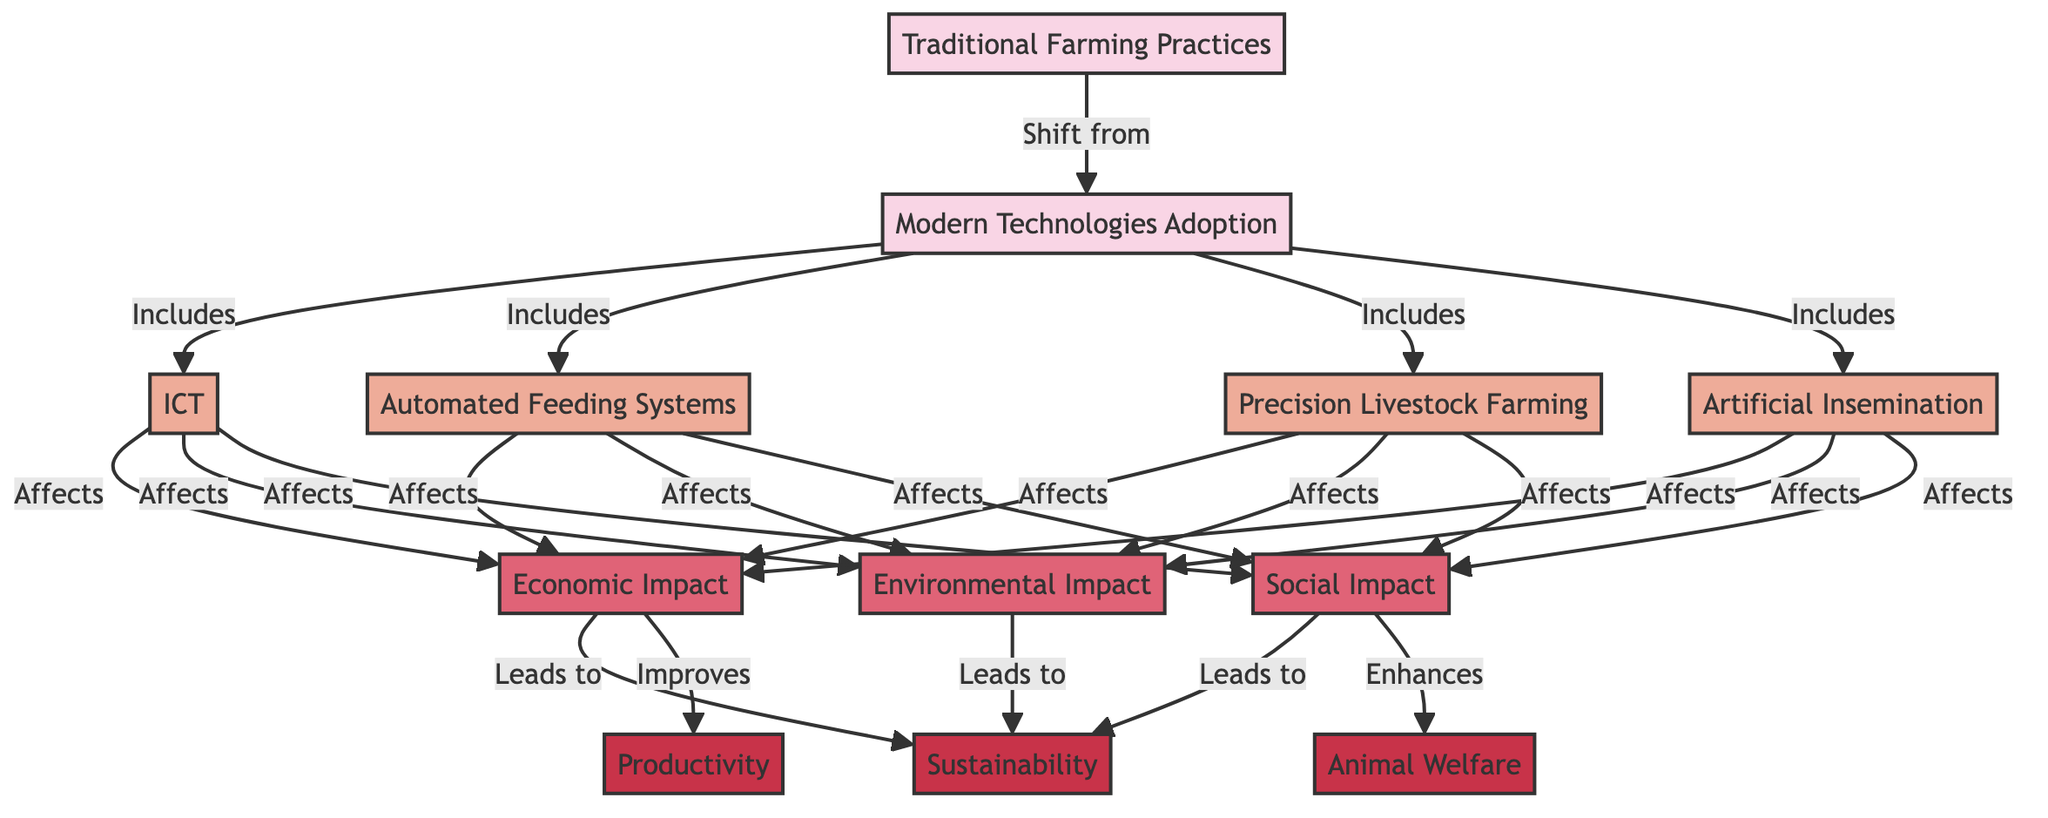What are the two main time periods shown in the diagram? The diagram clearly identifies two distinct time periods: "Traditional Farming Practices" and "Modern Technologies Adoption". These two nodes show the progression from one to the other.
Answer: Traditional Farming Practices, Modern Technologies Adoption How many modern technologies are listed in the diagram? The diagram includes four specific modern technologies: "ICT", "Automated Feeding Systems", "Precision Livestock Farming", and "Artificial Insemination". Counting these nodes yields a total of four technologies.
Answer: 4 What impact category is directly affected by the adoption of modern technologies? According to the diagram, the adoption of modern technologies affects three categories: "Economic Impact", "Environmental Impact", and "Social Impact". This is indicated by the arrows leading from the modern technologies to these impact categories.
Answer: Economic Impact, Environmental Impact, Social Impact What are the outcomes influenced by the economic impact? The diagram indicates that the "Economic Impact" leads to the outcome of "Productivity". This connection shows the direct relationship between economic factors and productivity outcomes in livestock management.
Answer: Productivity Which node indicates the enhancement of animal welfare? In the diagram, the "Social Impact" node has a direct relationship that "Enhances" the "Animal Welfare" outcome. This specifies that social improvements positively influence animal welfare.
Answer: Animal Welfare How does the shift from traditional to modern farming practices influence sustainability? The transition from "Traditional Farming Practices" to "Modern Technologies Adoption" indicates a shift that ultimately leads to enhanced "Sustainability", as shown by the arrows in the diagram. This suggests that modern practices contribute to long-term sustainability.
Answer: Sustainability What is the relationship between social impact and animal welfare? The diagram shows a directional relationship where the "Social Impact" leads to enhancements in "Animal Welfare". This implies that improvements in social aspects are positively correlated with animal welfare standards.
Answer: Enhances What is the color code representing outcomes in the diagram? The outcomes in the diagram are represented with a specific color code; they are filled with a shade corresponding to the class definition labeled as "outcome". Specifically, the color used is fill:#c83349.
Answer: fill:#c83349 